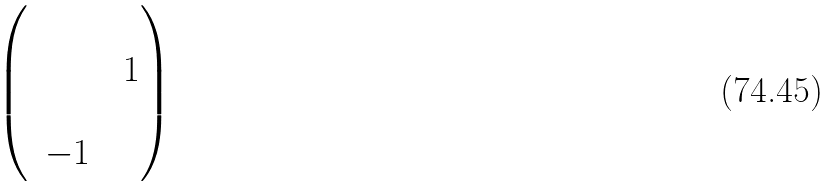<formula> <loc_0><loc_0><loc_500><loc_500>\begin{pmatrix} & & & \\ & & & 1 \\ & & & \\ & - 1 & & \\ \end{pmatrix}</formula> 